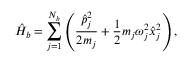<formula> <loc_0><loc_0><loc_500><loc_500>\hat { H } _ { b } = \sum _ { j = 1 } ^ { N _ { b } } \left ( \frac { \hat { p } _ { j } ^ { 2 } } { 2 m _ { j } } + \frac { 1 } { 2 } m _ { j } \omega _ { j } ^ { 2 } \hat { x } _ { j } ^ { 2 } \right ) ,</formula> 